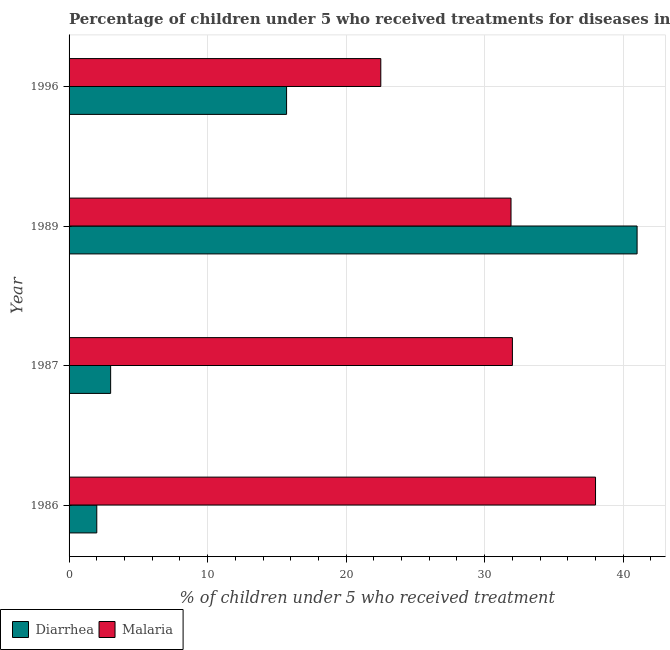How many different coloured bars are there?
Provide a succinct answer. 2. Are the number of bars per tick equal to the number of legend labels?
Your answer should be compact. Yes. How many bars are there on the 1st tick from the top?
Offer a terse response. 2. How many bars are there on the 3rd tick from the bottom?
Provide a short and direct response. 2. What is the label of the 1st group of bars from the top?
Offer a very short reply. 1996. In how many cases, is the number of bars for a given year not equal to the number of legend labels?
Offer a terse response. 0. What is the percentage of children who received treatment for malaria in 1989?
Make the answer very short. 31.9. In which year was the percentage of children who received treatment for malaria maximum?
Your answer should be very brief. 1986. What is the total percentage of children who received treatment for malaria in the graph?
Your answer should be very brief. 124.4. What is the difference between the percentage of children who received treatment for diarrhoea in 1987 and that in 1989?
Offer a terse response. -38. What is the difference between the percentage of children who received treatment for malaria in 1987 and the percentage of children who received treatment for diarrhoea in 1989?
Keep it short and to the point. -9. What is the average percentage of children who received treatment for diarrhoea per year?
Provide a succinct answer. 15.43. In the year 1996, what is the difference between the percentage of children who received treatment for malaria and percentage of children who received treatment for diarrhoea?
Ensure brevity in your answer.  6.8. What is the ratio of the percentage of children who received treatment for malaria in 1986 to that in 1996?
Your answer should be compact. 1.69. Is the percentage of children who received treatment for malaria in 1986 less than that in 1989?
Keep it short and to the point. No. Is the difference between the percentage of children who received treatment for malaria in 1989 and 1996 greater than the difference between the percentage of children who received treatment for diarrhoea in 1989 and 1996?
Give a very brief answer. No. What is the difference between the highest and the second highest percentage of children who received treatment for malaria?
Your answer should be compact. 6. What does the 1st bar from the top in 1996 represents?
Give a very brief answer. Malaria. What does the 2nd bar from the bottom in 1987 represents?
Make the answer very short. Malaria. What is the title of the graph?
Keep it short and to the point. Percentage of children under 5 who received treatments for diseases in Mali. What is the label or title of the X-axis?
Ensure brevity in your answer.  % of children under 5 who received treatment. What is the label or title of the Y-axis?
Ensure brevity in your answer.  Year. What is the % of children under 5 who received treatment in Diarrhea in 1987?
Make the answer very short. 3. What is the % of children under 5 who received treatment of Diarrhea in 1989?
Keep it short and to the point. 41. What is the % of children under 5 who received treatment in Malaria in 1989?
Your answer should be very brief. 31.9. Across all years, what is the maximum % of children under 5 who received treatment of Diarrhea?
Ensure brevity in your answer.  41. Across all years, what is the maximum % of children under 5 who received treatment of Malaria?
Your answer should be very brief. 38. What is the total % of children under 5 who received treatment of Diarrhea in the graph?
Offer a very short reply. 61.7. What is the total % of children under 5 who received treatment in Malaria in the graph?
Your answer should be compact. 124.4. What is the difference between the % of children under 5 who received treatment of Malaria in 1986 and that in 1987?
Your answer should be compact. 6. What is the difference between the % of children under 5 who received treatment in Diarrhea in 1986 and that in 1989?
Give a very brief answer. -39. What is the difference between the % of children under 5 who received treatment of Diarrhea in 1986 and that in 1996?
Give a very brief answer. -13.7. What is the difference between the % of children under 5 who received treatment in Diarrhea in 1987 and that in 1989?
Give a very brief answer. -38. What is the difference between the % of children under 5 who received treatment of Diarrhea in 1989 and that in 1996?
Provide a succinct answer. 25.3. What is the difference between the % of children under 5 who received treatment of Diarrhea in 1986 and the % of children under 5 who received treatment of Malaria in 1989?
Offer a terse response. -29.9. What is the difference between the % of children under 5 who received treatment in Diarrhea in 1986 and the % of children under 5 who received treatment in Malaria in 1996?
Provide a short and direct response. -20.5. What is the difference between the % of children under 5 who received treatment in Diarrhea in 1987 and the % of children under 5 who received treatment in Malaria in 1989?
Provide a short and direct response. -28.9. What is the difference between the % of children under 5 who received treatment in Diarrhea in 1987 and the % of children under 5 who received treatment in Malaria in 1996?
Ensure brevity in your answer.  -19.5. What is the average % of children under 5 who received treatment in Diarrhea per year?
Offer a terse response. 15.43. What is the average % of children under 5 who received treatment of Malaria per year?
Your response must be concise. 31.1. In the year 1986, what is the difference between the % of children under 5 who received treatment of Diarrhea and % of children under 5 who received treatment of Malaria?
Your response must be concise. -36. In the year 1989, what is the difference between the % of children under 5 who received treatment in Diarrhea and % of children under 5 who received treatment in Malaria?
Offer a very short reply. 9.1. In the year 1996, what is the difference between the % of children under 5 who received treatment of Diarrhea and % of children under 5 who received treatment of Malaria?
Give a very brief answer. -6.8. What is the ratio of the % of children under 5 who received treatment of Diarrhea in 1986 to that in 1987?
Your answer should be very brief. 0.67. What is the ratio of the % of children under 5 who received treatment of Malaria in 1986 to that in 1987?
Make the answer very short. 1.19. What is the ratio of the % of children under 5 who received treatment in Diarrhea in 1986 to that in 1989?
Give a very brief answer. 0.05. What is the ratio of the % of children under 5 who received treatment of Malaria in 1986 to that in 1989?
Your response must be concise. 1.19. What is the ratio of the % of children under 5 who received treatment in Diarrhea in 1986 to that in 1996?
Offer a very short reply. 0.13. What is the ratio of the % of children under 5 who received treatment of Malaria in 1986 to that in 1996?
Give a very brief answer. 1.69. What is the ratio of the % of children under 5 who received treatment in Diarrhea in 1987 to that in 1989?
Give a very brief answer. 0.07. What is the ratio of the % of children under 5 who received treatment in Malaria in 1987 to that in 1989?
Offer a terse response. 1. What is the ratio of the % of children under 5 who received treatment of Diarrhea in 1987 to that in 1996?
Keep it short and to the point. 0.19. What is the ratio of the % of children under 5 who received treatment in Malaria in 1987 to that in 1996?
Ensure brevity in your answer.  1.42. What is the ratio of the % of children under 5 who received treatment in Diarrhea in 1989 to that in 1996?
Provide a succinct answer. 2.61. What is the ratio of the % of children under 5 who received treatment of Malaria in 1989 to that in 1996?
Offer a terse response. 1.42. What is the difference between the highest and the second highest % of children under 5 who received treatment in Diarrhea?
Give a very brief answer. 25.3. What is the difference between the highest and the lowest % of children under 5 who received treatment in Diarrhea?
Provide a short and direct response. 39. 